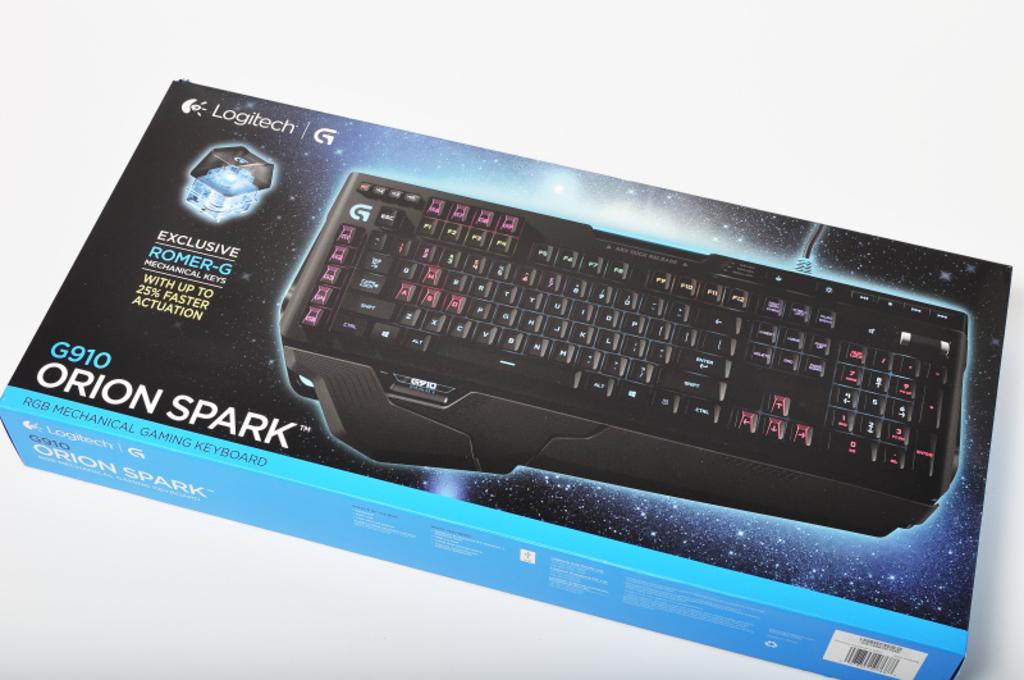What would you use this keyboard for?
Offer a terse response. Gaming. What is the model number?
Provide a succinct answer. G910. 